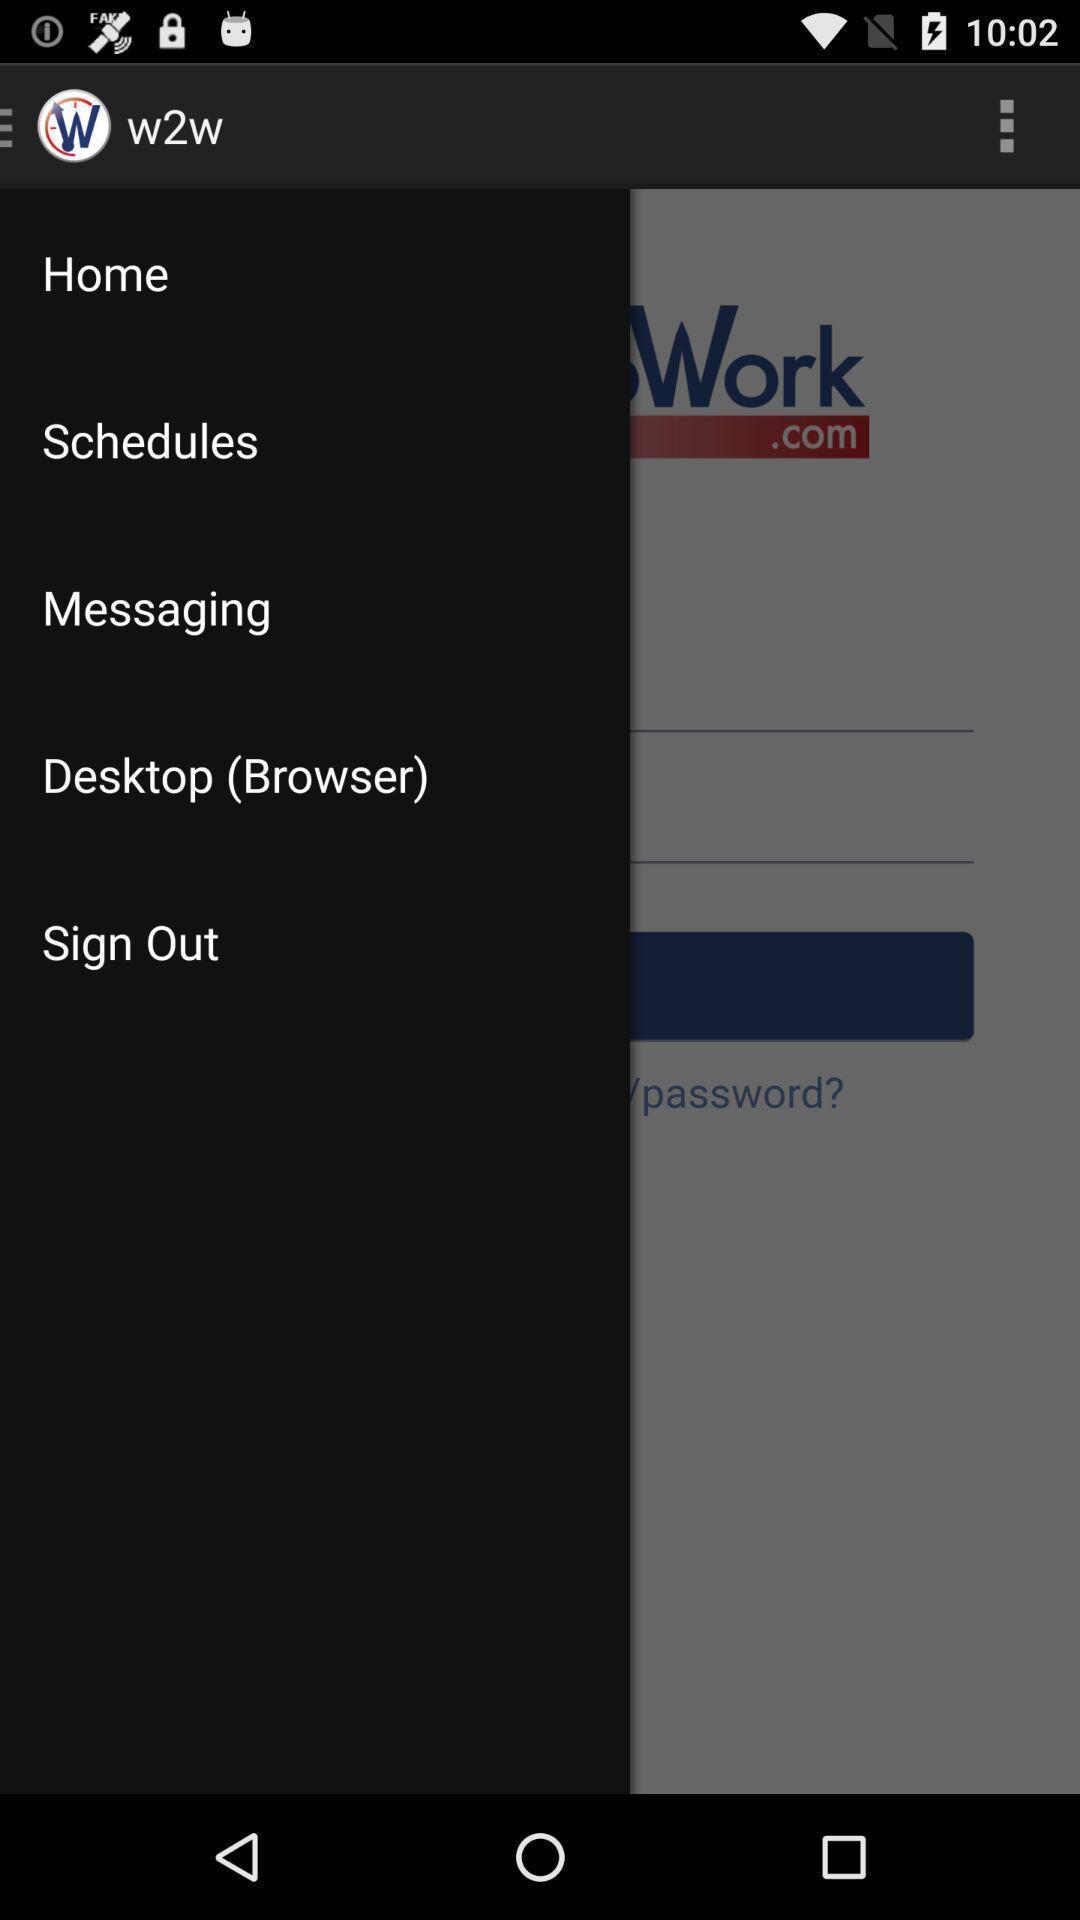Summarize the main components in this picture. Sign out page. 